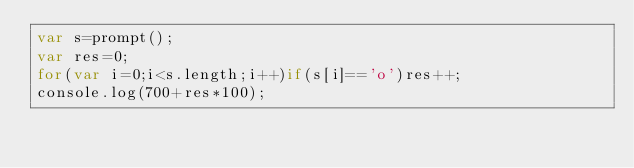Convert code to text. <code><loc_0><loc_0><loc_500><loc_500><_JavaScript_>var s=prompt();
var res=0;
for(var i=0;i<s.length;i++)if(s[i]=='o')res++;
console.log(700+res*100);</code> 